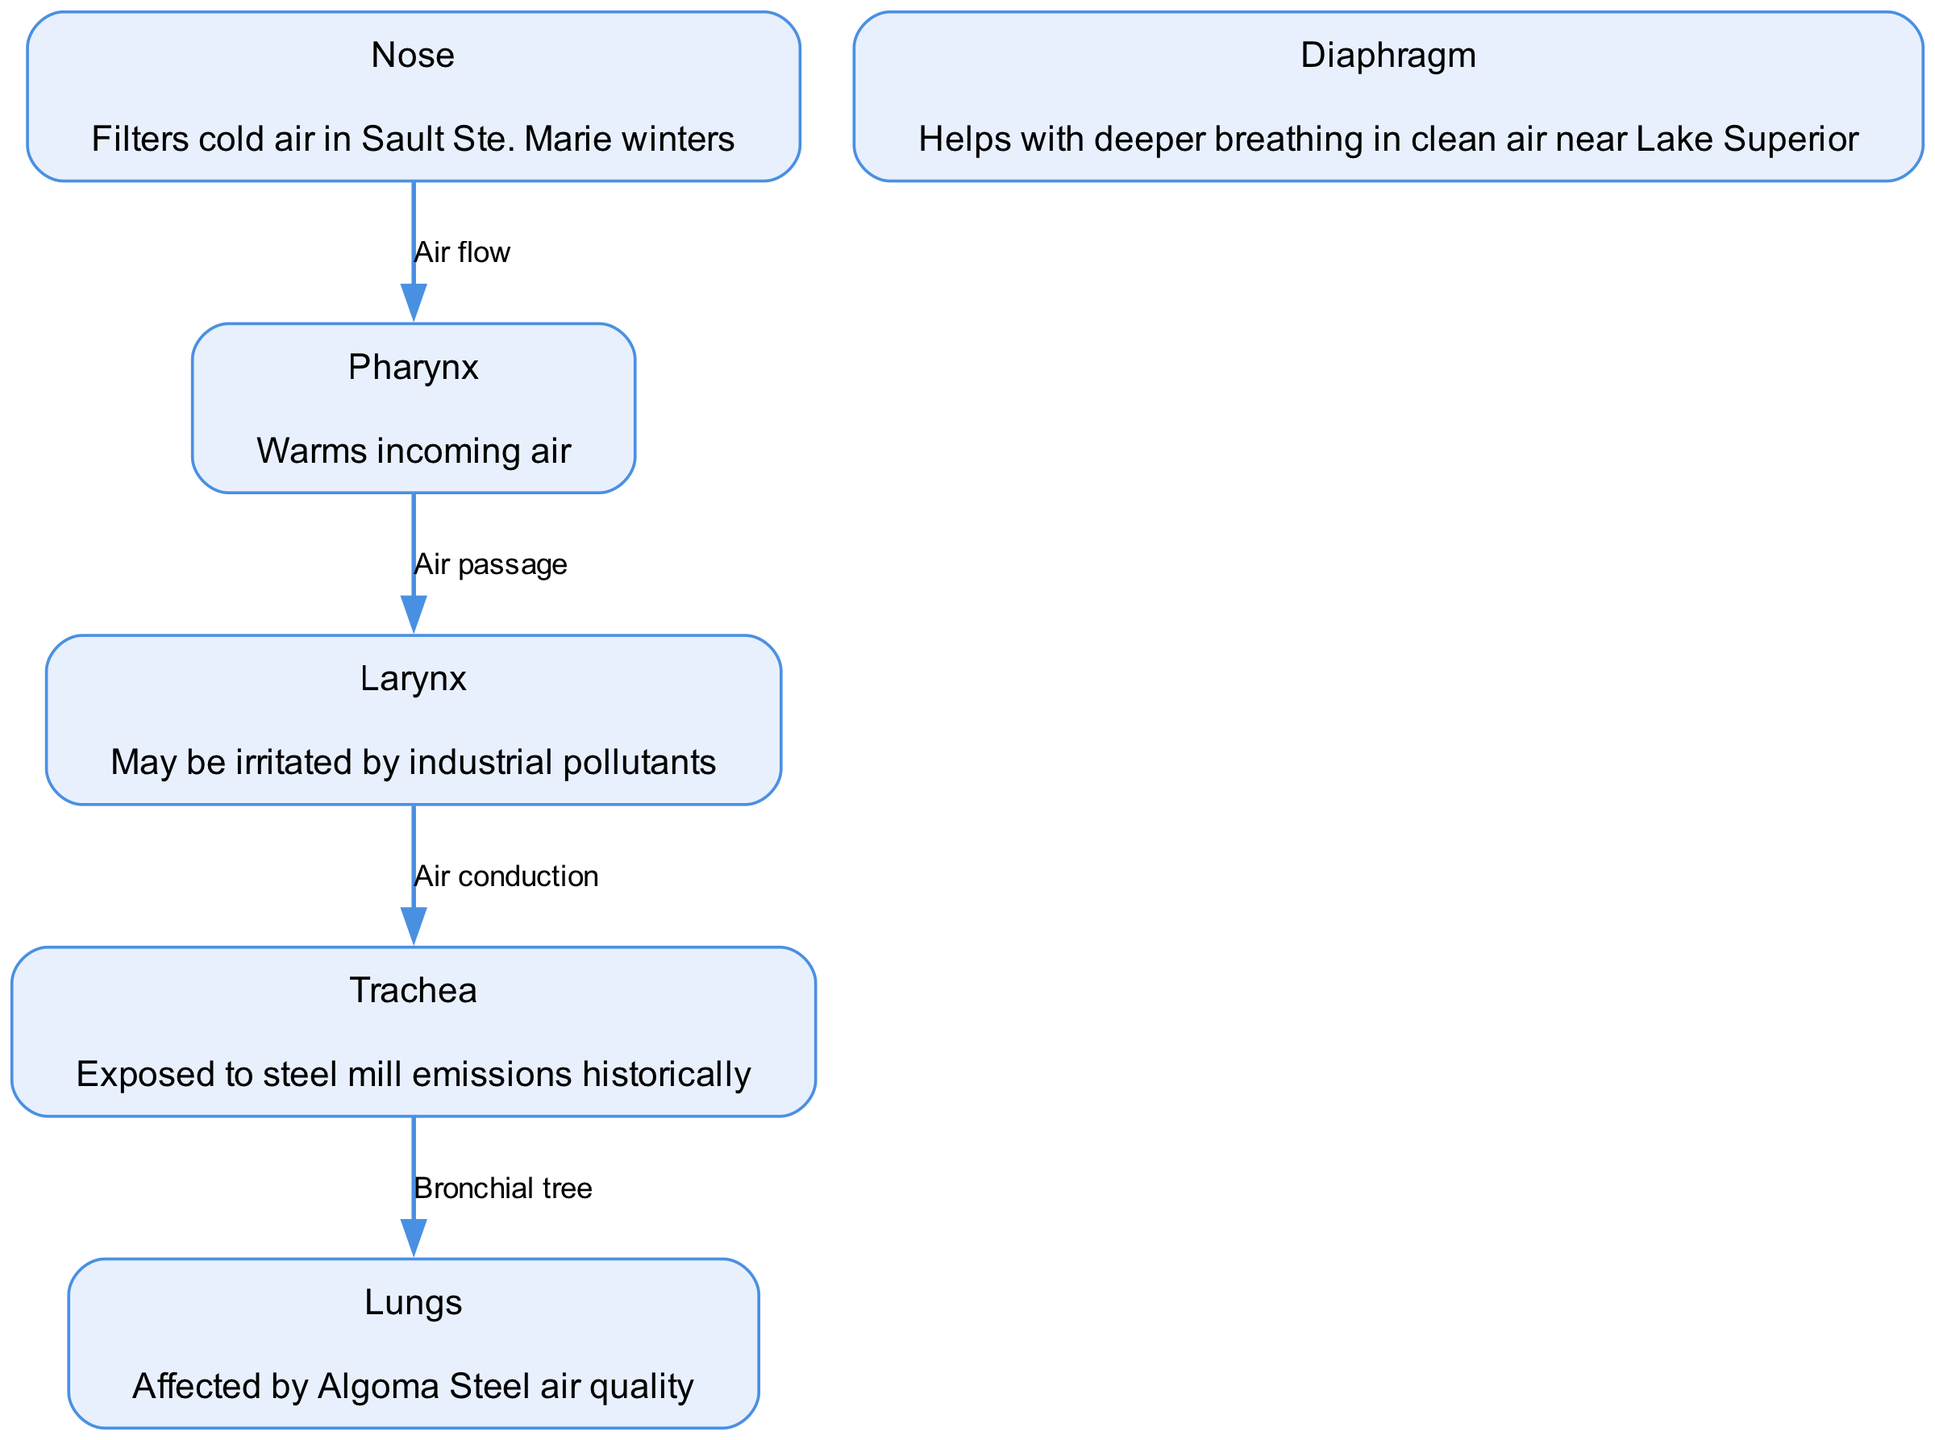What is the first structure in the air flow? The diagram shows air flow starting at the "Nose," which is noted as the first structure that filters air.
Answer: Nose How many nodes are there in the diagram? The diagram contains a total of six nodes, each representing different parts of the human respiratory system.
Answer: 6 What role does the pharynx play in the respiratory system? The pharynx is described as the structure that warms incoming air before it continues further into the respiratory system.
Answer: Warms incoming air Which structure might get irritated by pollutants? The "Larynx" is noted in the diagram as a structure that may be irritated by industrial pollutants, indicating its vulnerability to air quality issues.
Answer: Larynx What effect does the climate have on the functioning of the diaphragm? The diaphragm's function is enhanced for deeper breathing due to the cleaner air found near Lake Superior, illustrating the impact of local climate on respiratory health.
Answer: Clean air near Lake Superior How is air conducted from the larynx to the trachea? The diagram shows that air is conducted from the larynx to the trachea, indicating a direct passage for air during breathing.
Answer: Air conduction Which structure is historically exposed to steel mill emissions? The trachea is indicated in the diagram as being historically exposed to steel mill emissions, highlighting environmental impacts on respiratory health.
Answer: Trachea What is the last node in the air passage? The "Lungs" is the last node in the air passage, receiving air from the trachea before it enters.
Answer: Lungs How does the local climate influence air passage through the nose? The nose filters cold air during Sault Ste. Marie winters, demonstrating how the local climate directly affects this initial stage of air passage.
Answer: Filters cold air in Sault Ste. Marie winters 